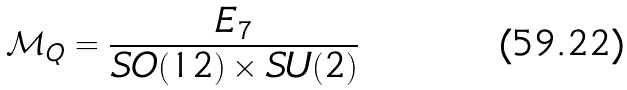Convert formula to latex. <formula><loc_0><loc_0><loc_500><loc_500>\mathcal { M } _ { Q } = \frac { E _ { 7 } } { S O ( 1 2 ) \times S U ( 2 ) }</formula> 